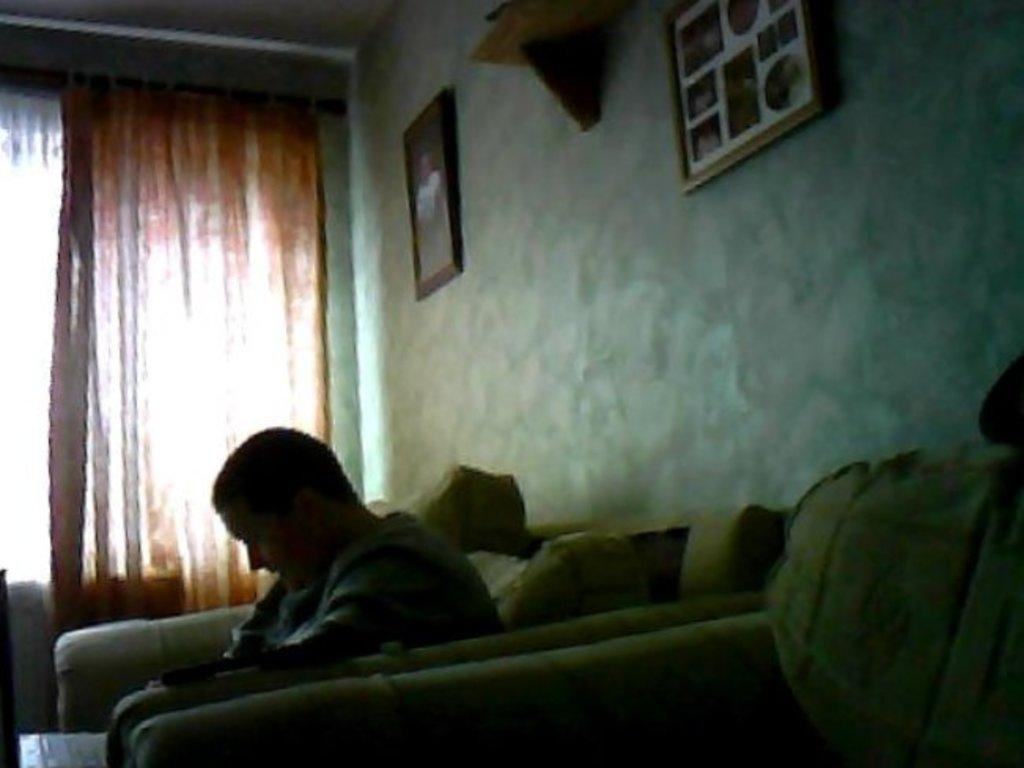What is the person in the image doing? There is a person sitting on a couch in the image. What is on the couch with the person? There are cushions on the couch. What can be seen on the wall in the image? Photo frames are present on the wall. What type of object is visible in the image? There is a decorative object in the image. What is used to cover the window in the image? There is a curtain in the image. What type of shoes is the person wearing in the image? The image does not show the person's feet or any shoes, so it cannot be determined what type of shoes they might be wearing. 